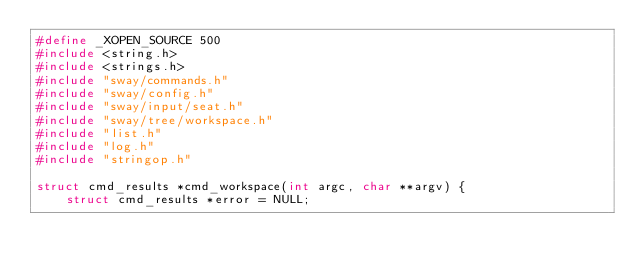<code> <loc_0><loc_0><loc_500><loc_500><_C_>#define _XOPEN_SOURCE 500
#include <string.h>
#include <strings.h>
#include "sway/commands.h"
#include "sway/config.h"
#include "sway/input/seat.h"
#include "sway/tree/workspace.h"
#include "list.h"
#include "log.h"
#include "stringop.h"

struct cmd_results *cmd_workspace(int argc, char **argv) {
	struct cmd_results *error = NULL;</code> 